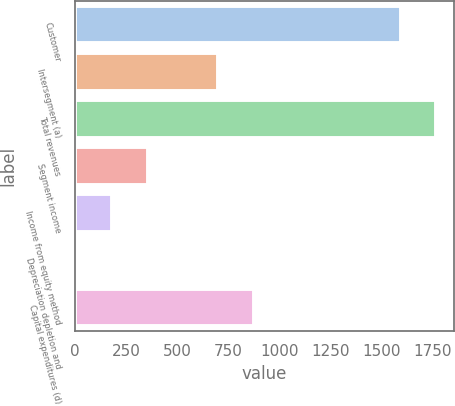Convert chart. <chart><loc_0><loc_0><loc_500><loc_500><bar_chart><fcel>Customer<fcel>Intersegment (a)<fcel>Total revenues<fcel>Segment income<fcel>Income from equity method<fcel>Depreciation depletion and<fcel>Capital expenditures (d)<nl><fcel>1593<fcel>700.4<fcel>1766.1<fcel>354.2<fcel>181.1<fcel>8<fcel>873.5<nl></chart> 